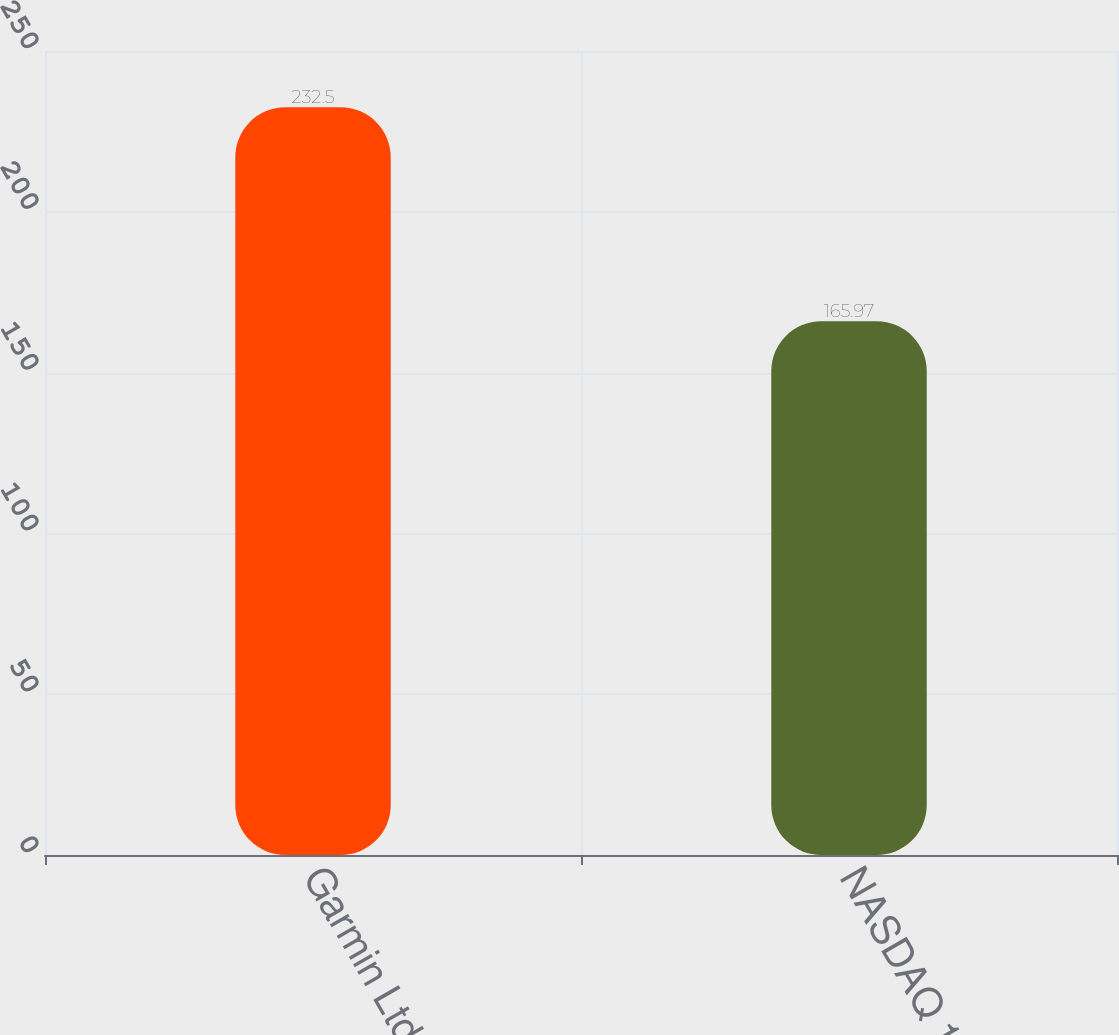Convert chart to OTSL. <chart><loc_0><loc_0><loc_500><loc_500><bar_chart><fcel>Garmin Ltd<fcel>NASDAQ 100<nl><fcel>232.5<fcel>165.97<nl></chart> 